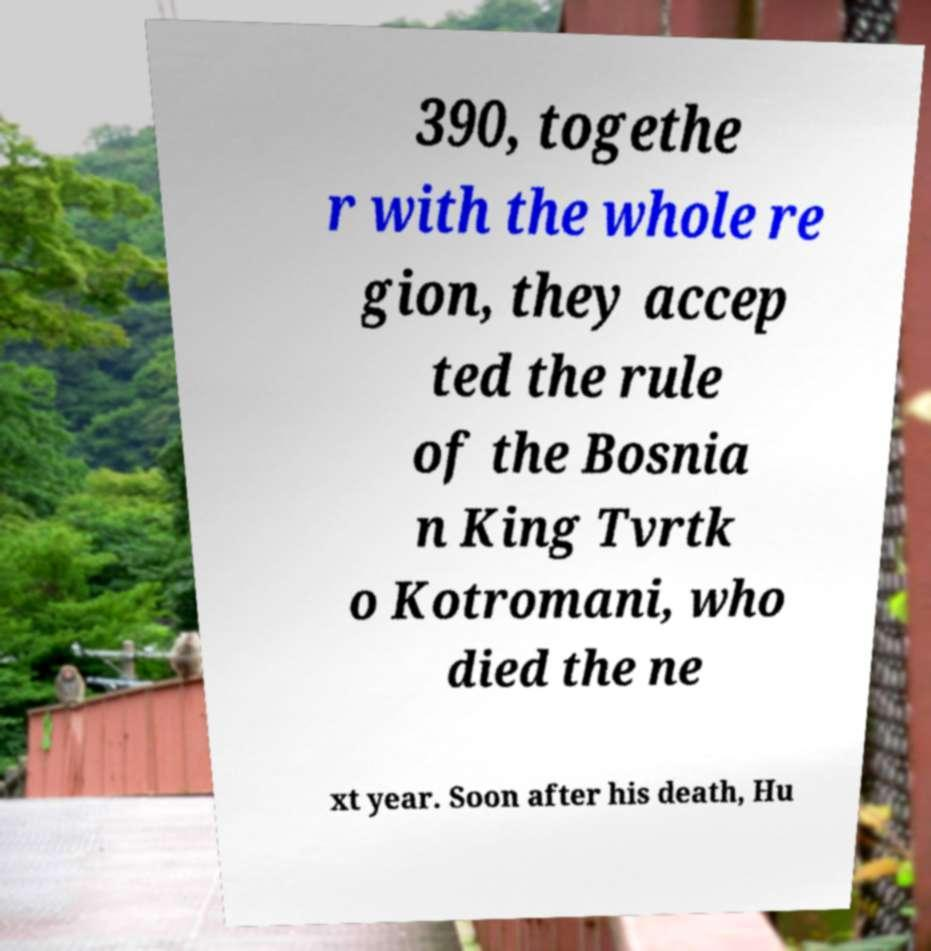Can you read and provide the text displayed in the image?This photo seems to have some interesting text. Can you extract and type it out for me? 390, togethe r with the whole re gion, they accep ted the rule of the Bosnia n King Tvrtk o Kotromani, who died the ne xt year. Soon after his death, Hu 